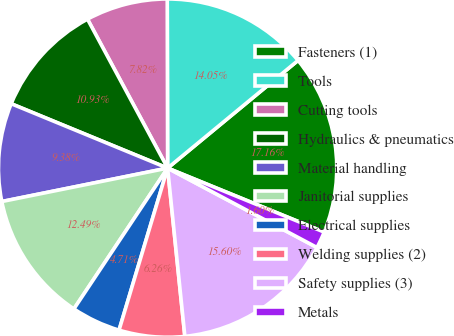Convert chart to OTSL. <chart><loc_0><loc_0><loc_500><loc_500><pie_chart><fcel>Fasteners (1)<fcel>Tools<fcel>Cutting tools<fcel>Hydraulics & pneumatics<fcel>Material handling<fcel>Janitorial supplies<fcel>Electrical supplies<fcel>Welding supplies (2)<fcel>Safety supplies (3)<fcel>Metals<nl><fcel>17.16%<fcel>14.05%<fcel>7.82%<fcel>10.93%<fcel>9.38%<fcel>12.49%<fcel>4.71%<fcel>6.26%<fcel>15.6%<fcel>1.6%<nl></chart> 